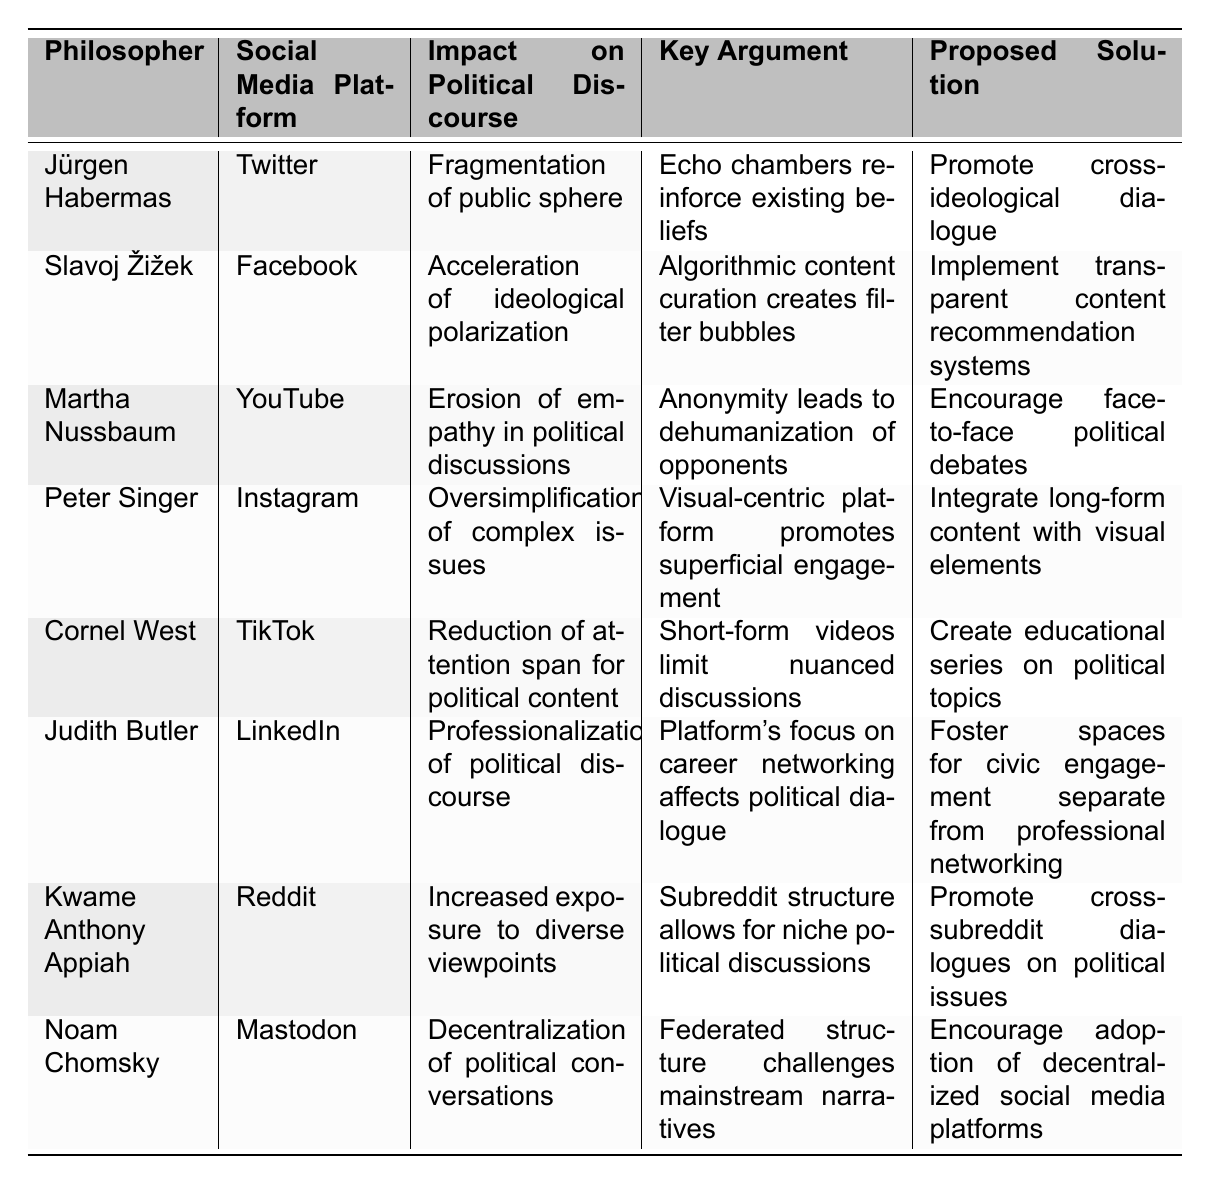What impact on political discourse is associated with Jürgen Habermas's views? According to the table, Jürgen Habermas associates with the impact of fragmentation of the public sphere. This suggests he believes that social media contributes to a divided political climate.
Answer: Fragmentation of public sphere Which social media platform is linked to Slavoj Žižek's argument regarding ideological polarization? The table indicates that Slavoj Žižek links his argument about the acceleration of ideological polarization to Facebook. He argues that the platform's algorithm leads to filter bubbles.
Answer: Facebook What is the key argument made by Martha Nussbaum regarding YouTube? Martha Nussbaum argues that the anonymity on YouTube leads to the erosion of empathy in political discussions, which means that users may become desensitized to opposing views.
Answer: Anonymity leads to dehumanization of opponents Which philosopher suggests fostering cross-ideological dialogue as a solution to the impact of Twitter on political discourse? Jürgen Habermas is the philosopher who proposes promoting cross-ideological dialogue as a solution to the fragmentation caused by Twitter.
Answer: Jürgen Habermas How many philosophers discussed the impact of TikTok in the table? The table shows that only one philosopher, Cornel West, discusses the impact of TikTok on political discourse, focusing on the reduction of attention span for political content.
Answer: One philosopher What is the proposed solution by Peter Singer regarding the oversimplification of complex issues on Instagram? Peter Singer proposes integrating long-form content with visual elements as a solution to counter the oversimplification of complex issues on Instagram.
Answer: Integrate long-form content with visual elements Does Noam Chomsky believe that social media can decentralize political conversations? Yes, according to the table, Noam Chomsky states that the federated structure of Mastodon challenges mainstream narratives, indicating a belief in decentralization.
Answer: Yes Which social media platform is associated with the potential for increased exposure to diverse viewpoints, according to Kwame Anthony Appiah? Kwame Anthony Appiah notes that Reddit is associated with the potential for increased exposure to diverse viewpoints due to its subreddit structure.
Answer: Reddit What common theme can be identified in the proposed solutions from the philosophers in the table? A common theme is the emphasis on fostering dialogue and civic engagement to mitigate the negative impacts of social media on political discourse, as illustrated by various proposed solutions.
Answer: Fostering dialogue and civic engagement Which philosopher suggests a need for transparent content recommendation systems, and what is the related social media platform? Slavoj Žižek suggests the need for transparent content recommendation systems, related to the impact of Facebook on political polarization.
Answer: Slavoj Žižek; Facebook 